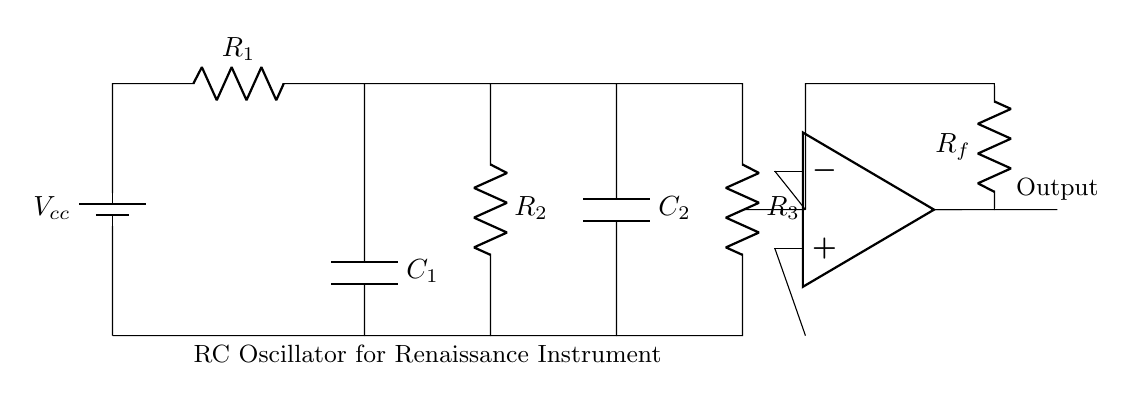What is the function of C1 in the circuit? C1 acts as a timing element in the RC oscillator, controlling the charge and discharge cycles that generate the oscillation frequency.
Answer: Timing element What are the two capacitors in the circuit? The two capacitors in the circuit are C1 and C2, which are used for timing and frequency control in the oscillator.
Answer: C1 and C2 What is the purpose of the resistor Rf? Rf functions as a feedback resistor that helps set the gain of the operational amplifier, influencing the output amplitude of the oscillation.
Answer: Feedback resistor How many resistors are present in the circuit? There are three resistors indicated by R1, R2, and R3, which contribute to the time constant of the RC oscillator.
Answer: Three What is the output nature of the circuit? The output is an oscillating signal generated by the operational amplifier, resulting from the charge and discharge cycles of the capacitors.
Answer: Oscillating signal Explain the role of the operational amplifier in this circuit. The operational amplifier amplifies the voltage across the capacitors and creates feedback that sustains oscillations, maintaining the waveform of the output signal.
Answer: Amplifies voltage 